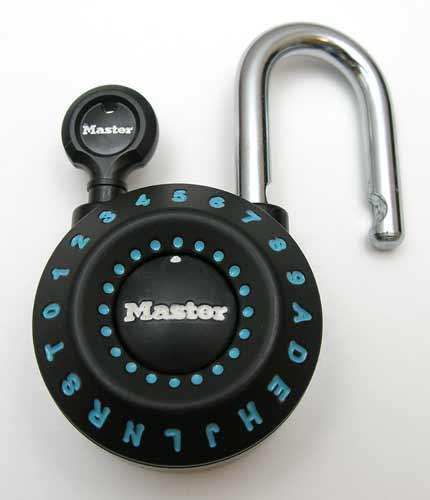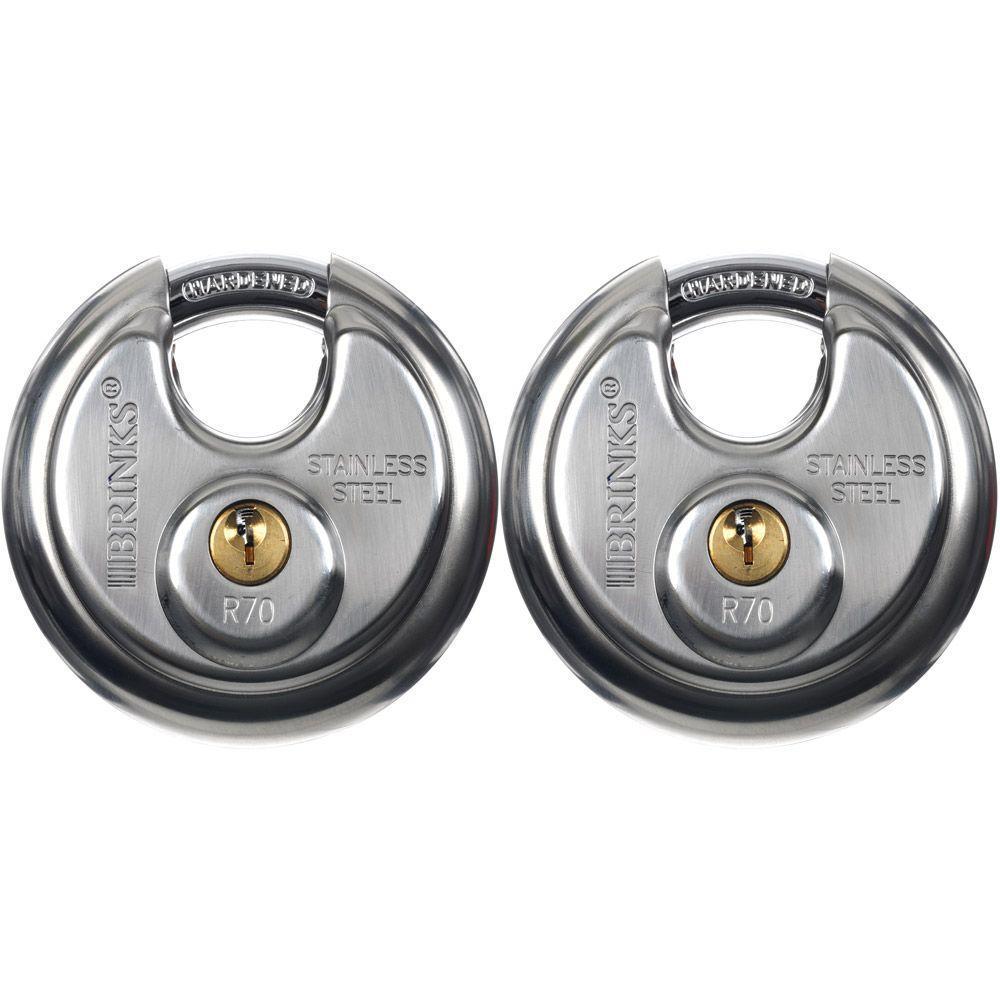The first image is the image on the left, the second image is the image on the right. Evaluate the accuracy of this statement regarding the images: "There are at most 3 padlocks in total.". Is it true? Answer yes or no. Yes. 